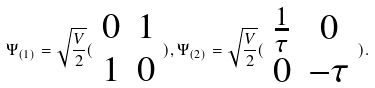Convert formula to latex. <formula><loc_0><loc_0><loc_500><loc_500>\Psi _ { ( 1 ) } = \sqrt { \frac { V } { 2 } } ( \begin{array} { c c } 0 & 1 \\ 1 & 0 \end{array} ) , \Psi _ { ( 2 ) } = \sqrt { \frac { V } { 2 } } ( \begin{array} { c c } \frac { 1 } { \tau } & 0 \\ 0 & - \tau \end{array} ) .</formula> 